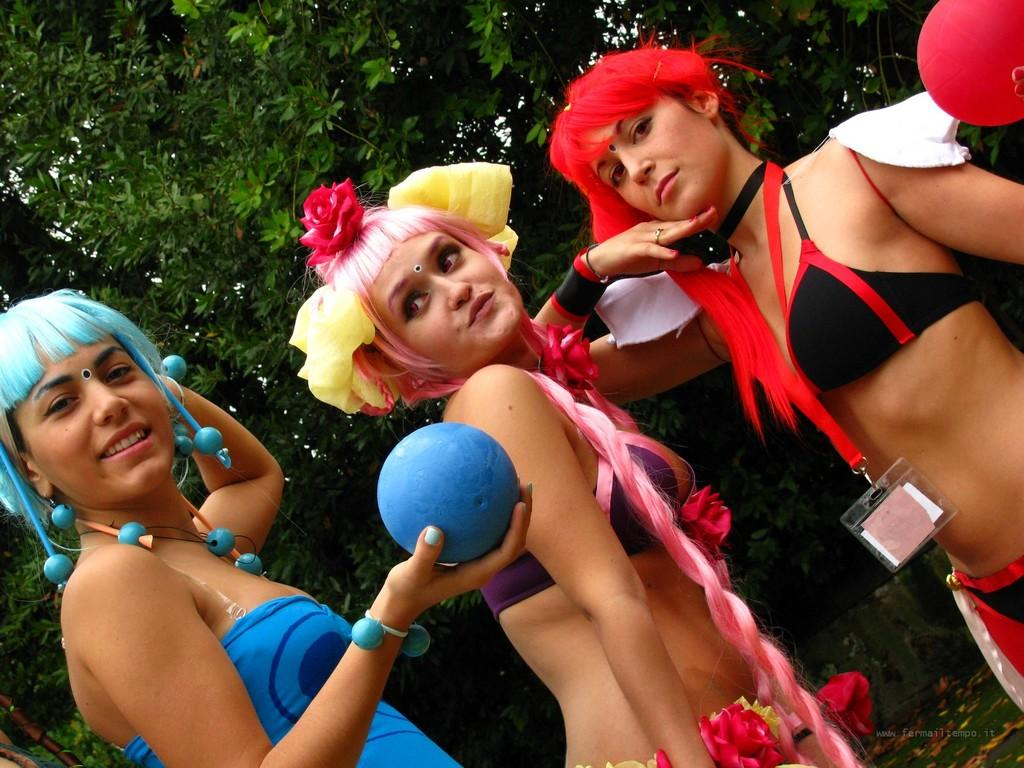How many people are in the image? There are three persons standing at the bottom of the image. What are the persons holding in their hands? The persons are holding some balls. What can be seen in the background of the image? There are trees visible behind the persons. How much money is being exchanged between the persons in the image? There is no mention of money or any exchange of money in the image. The persons are holding balls, not money. 